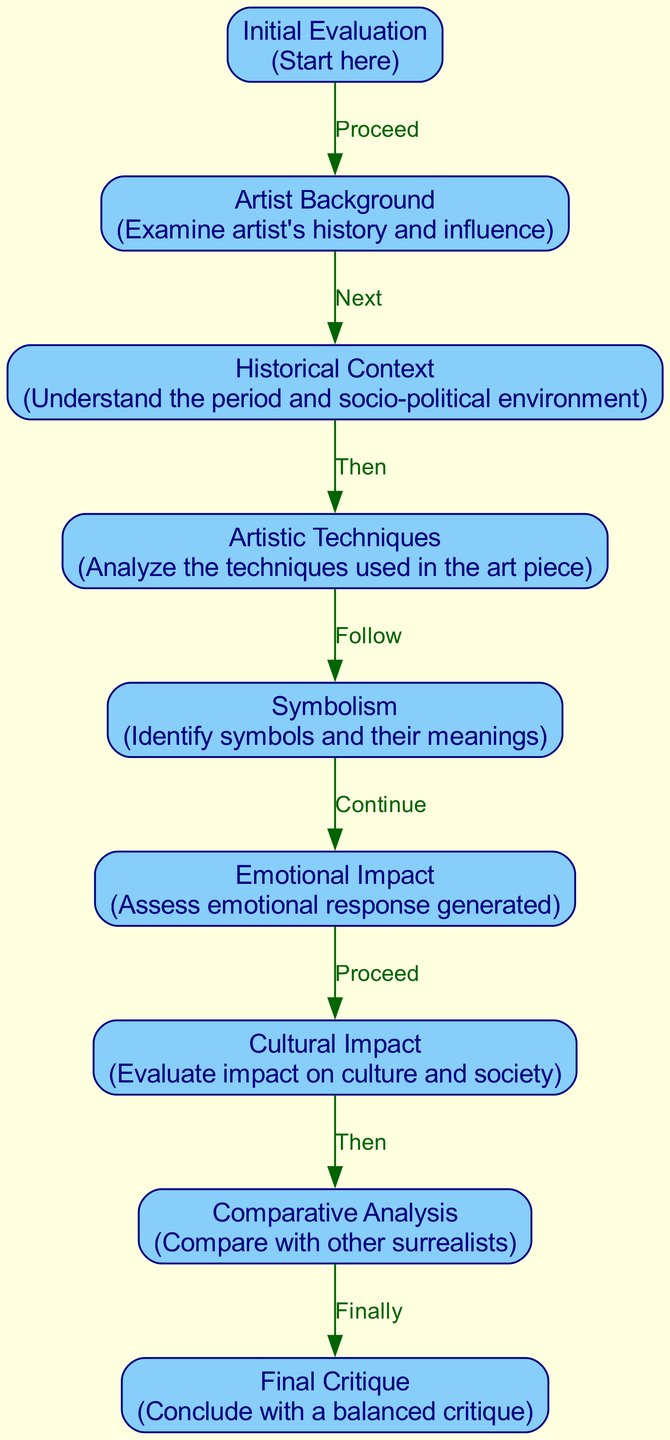What is the first step in the critique framework? The diagram starts with the node labeled "Initial Evaluation," indicating it's the first step in the critique process.
Answer: Initial Evaluation How many nodes are present in the diagram? To determine the number of nodes, we count all the unique steps from the diagram, which includes "Initial Evaluation," "Artist Background," "Historical Context," "Artistic Techniques," "Symbolism," "Emotional Impact," "Cultural Impact," "Comparative Analysis," and "Final Critique." This totals nine nodes.
Answer: 9 What is the label of the node that follows "Emotional Impact"? According to the flow of the diagram, the node immediately succeeding "Emotional Impact" is labeled "Cultural Impact."
Answer: Cultural Impact Which criteria comes after analyzing artistic techniques? In the sequence of evaluation, after "Artistic Techniques," the next criteria to examine is "Symbolism," as indicated by the flow between the nodes in the diagram.
Answer: Symbolism How does "Comparative Analysis" relate to the previous nodes? "Comparative Analysis" follows "Cultural Impact," indicating that it builds upon the evaluation of cultural significance. In this context, it compares the piece with other surrealist artists, reflecting on the overall understanding derived from previous evaluations.
Answer: Builds upon Cultural Impact What is the last step in the critique framework? The final step depicted in the diagram is labeled "Final Critique," which serves to conclude the evaluation process based on all previous analyses.
Answer: Final Critique How many edges are there in the diagram? To find the number of edges, we count the connections between nodes, which are the directional paths that illustrate the flow of evaluation. There are eight edges linking the nine nodes.
Answer: 8 What is the purpose of the "Artist Background" node? The purpose of the "Artist Background" node is to examine the artist's history and the influences that may have shaped their work, as noted in the description of this node.
Answer: Examine artist's history and influence What symbol reflects the assessment of emotional response? The node labeled "Emotional Impact" specifically reflects the assessment of emotional response generated by the artwork.
Answer: Emotional Impact 